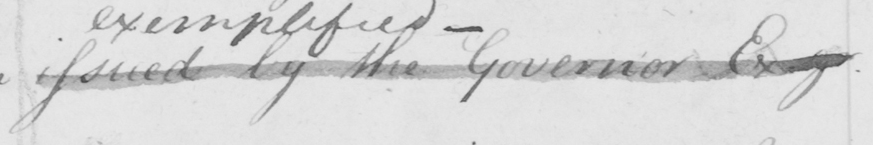Please provide the text content of this handwritten line. issued by the Governor Esq . 